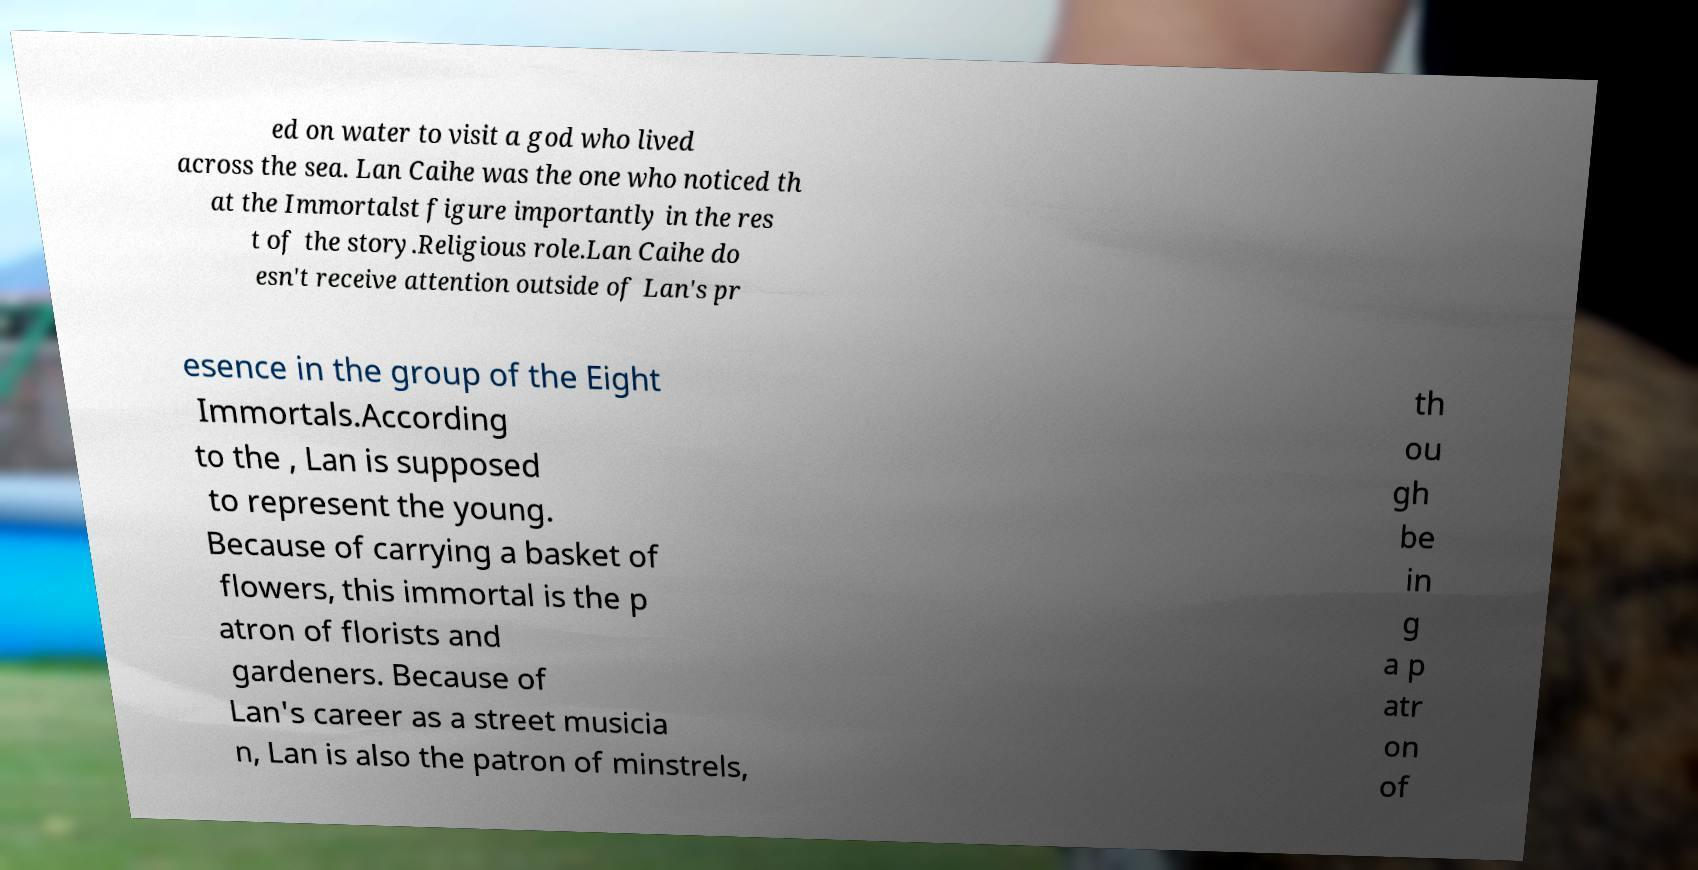Can you read and provide the text displayed in the image?This photo seems to have some interesting text. Can you extract and type it out for me? ed on water to visit a god who lived across the sea. Lan Caihe was the one who noticed th at the Immortalst figure importantly in the res t of the story.Religious role.Lan Caihe do esn't receive attention outside of Lan's pr esence in the group of the Eight Immortals.According to the , Lan is supposed to represent the young. Because of carrying a basket of flowers, this immortal is the p atron of florists and gardeners. Because of Lan's career as a street musicia n, Lan is also the patron of minstrels, th ou gh be in g a p atr on of 